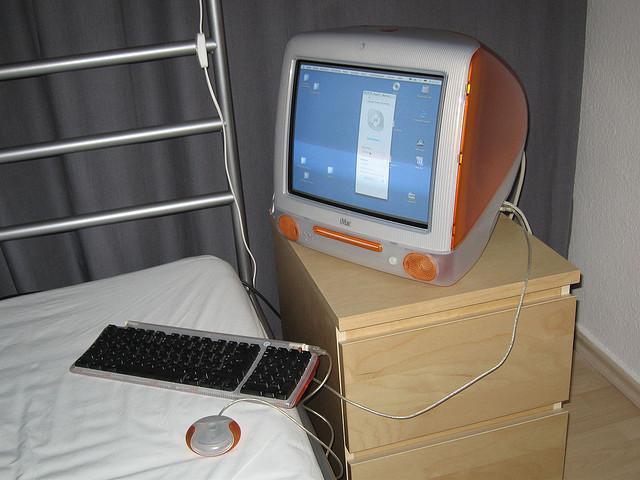What is sitting on the dresser?
Choose the correct response and explain in the format: 'Answer: answer
Rationale: rationale.'
Options: Monitor, tablet, phone, kindle. Answer: monitor.
Rationale: It is connected to a mouse and computer keyboard. 